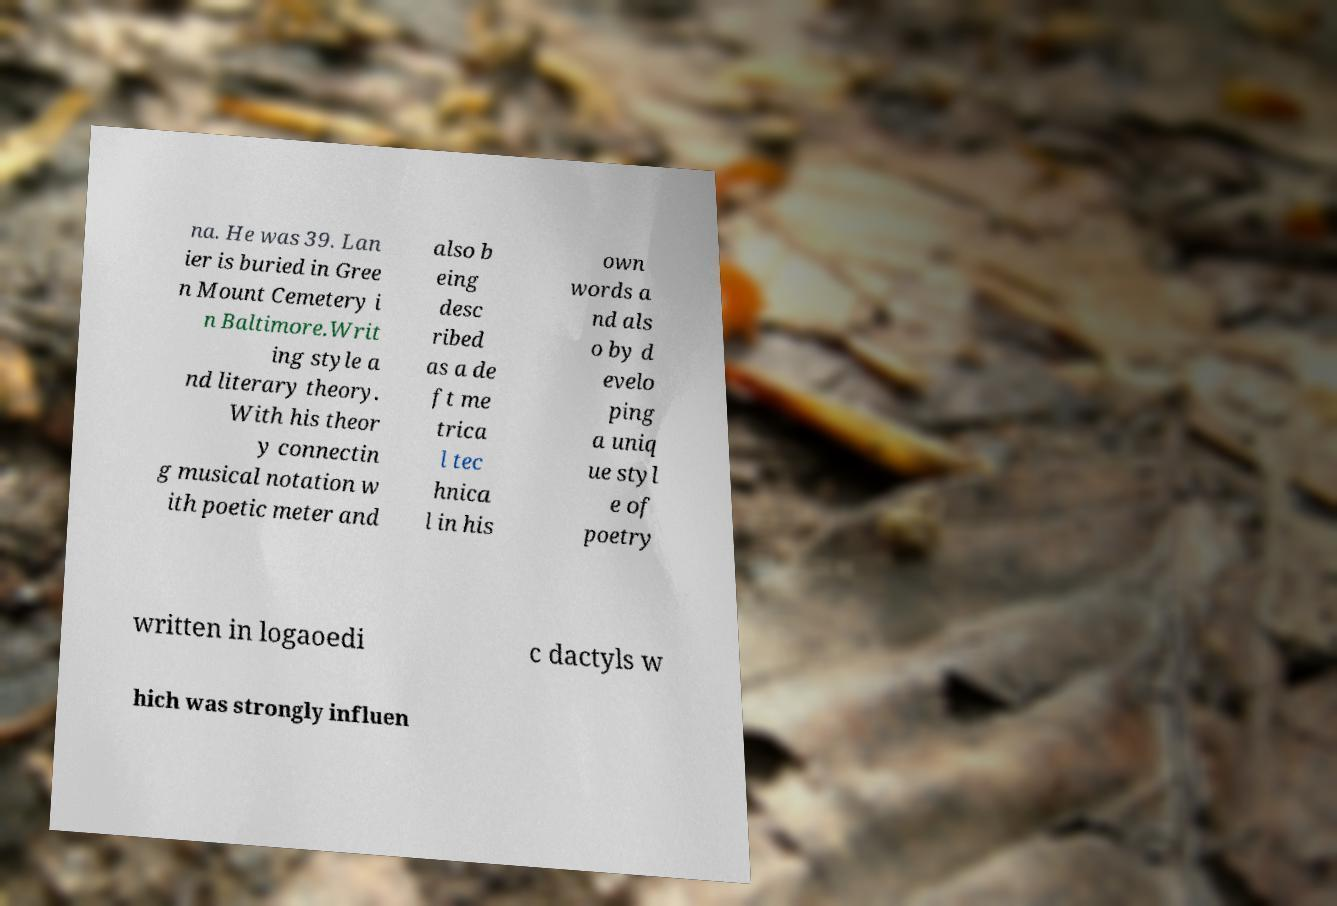Can you accurately transcribe the text from the provided image for me? na. He was 39. Lan ier is buried in Gree n Mount Cemetery i n Baltimore.Writ ing style a nd literary theory. With his theor y connectin g musical notation w ith poetic meter and also b eing desc ribed as a de ft me trica l tec hnica l in his own words a nd als o by d evelo ping a uniq ue styl e of poetry written in logaoedi c dactyls w hich was strongly influen 